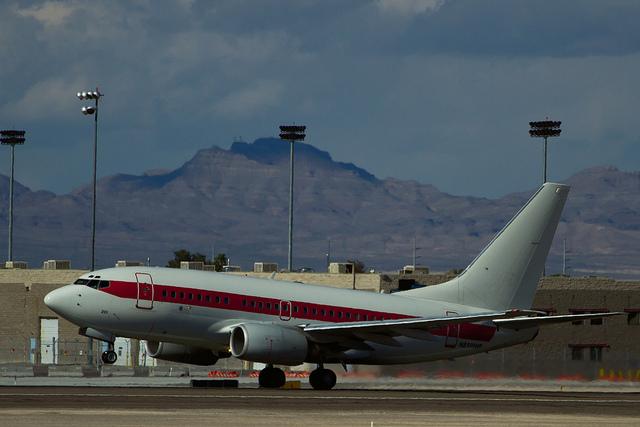What color is the stripe on the plane?
Write a very short answer. Red. Is the vehicle in the photo currently in motion?
Write a very short answer. No. How many KLM planes can you spot?
Be succinct. 1. What is the sitting capacity of this airplane?
Write a very short answer. 100. How many plans are taking off?
Be succinct. 1. How many planes are there?
Write a very short answer. 1. Is there most likely a pilot in this plane?
Concise answer only. Yes. 